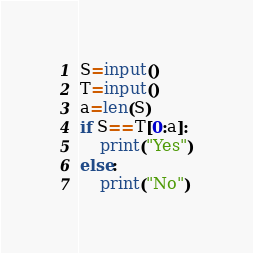Convert code to text. <code><loc_0><loc_0><loc_500><loc_500><_Python_>S=input()
T=input()
a=len(S)
if S==T[0:a]:
    print("Yes")
else:
    print("No")
</code> 